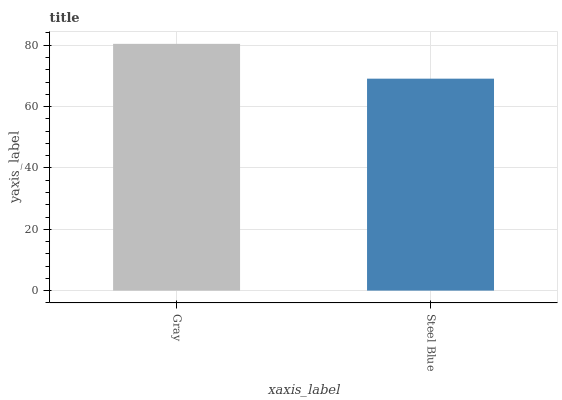Is Steel Blue the minimum?
Answer yes or no. Yes. Is Gray the maximum?
Answer yes or no. Yes. Is Steel Blue the maximum?
Answer yes or no. No. Is Gray greater than Steel Blue?
Answer yes or no. Yes. Is Steel Blue less than Gray?
Answer yes or no. Yes. Is Steel Blue greater than Gray?
Answer yes or no. No. Is Gray less than Steel Blue?
Answer yes or no. No. Is Gray the high median?
Answer yes or no. Yes. Is Steel Blue the low median?
Answer yes or no. Yes. Is Steel Blue the high median?
Answer yes or no. No. Is Gray the low median?
Answer yes or no. No. 